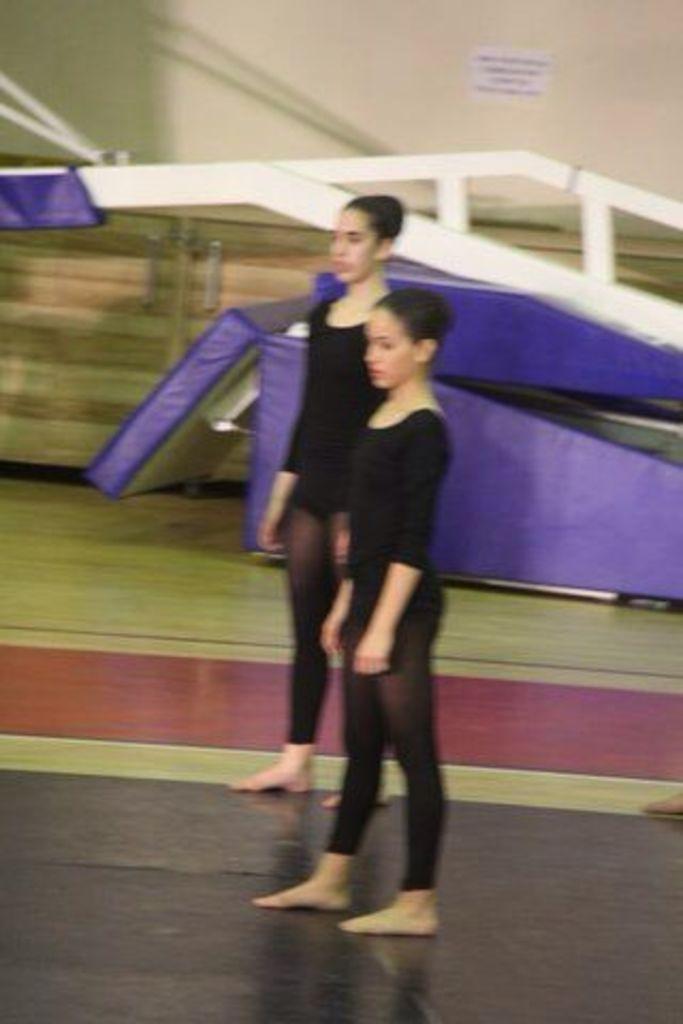Please provide a concise description of this image. In this image I can see in the middle two girls are standing, they are wearing black color t-shirts, trousers. In the background it looks like there are iron frames and there is a paper on the wall. 